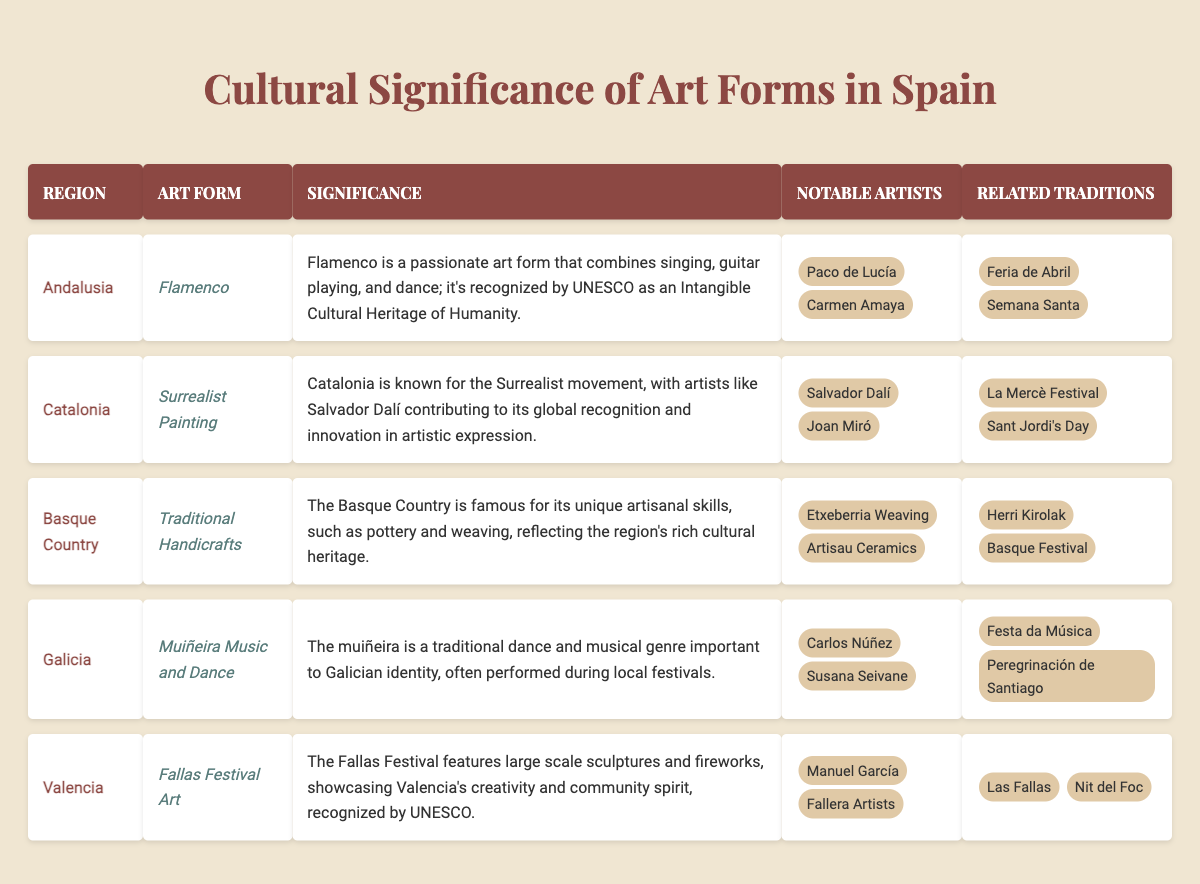What is the art form associated with Catalonia? The table specifies that the art form associated with Catalonia is Surrealist Painting.
Answer: Surrealist Painting Who are the notable artists from the Basque Country? According to the table, the notable artists from the Basque Country are Etxeberria Weaving and Artisau Ceramics.
Answer: Etxeberria Weaving, Artisau Ceramics Which region is known for Flamenco? The table reveals that Flamenco is the art form linked with the region of Andalusia.
Answer: Andalusia Is Muiñeira Music and Dance significant to Galician identity? The table states that Muiñeira Music and Dance is indeed important to Galician identity as it is often performed during local festivals.
Answer: Yes What are the related traditions for the Fallas Festival Art? The table lists the related traditions for the Fallas Festival Art as Las Fallas and Nit del Foc.
Answer: Las Fallas, Nit del Foc How many notable artists are associated with the art form of Flamenco? The table shows that there are 2 notable artists associated with Flamenco: Paco de Lucía and Carmen Amaya.
Answer: 2 Which region has both the art form and notable artists connected with Surrealism? The table indicates that Catalonia has the Surrealist Painting as its art form and notable artists like Salvador Dalí and Joan Miró.
Answer: Catalonia What is the total number of art forms listed in the table? The table includes 5 distinct art forms: Flamenco, Surrealist Painting, Traditional Handicrafts, Muiñeira Music and Dance, and Fallas Festival Art, leading to a total of 5.
Answer: 5 Is the Fallas Festival recognized by UNESCO? According to the table, the significance of Fallas Festival Art is highlighted as being recognized by UNESCO.
Answer: Yes What art form combines singing, guitar playing, and dance? The table specifies that Flamenco combines singing, guitar playing, and dance.
Answer: Flamenco 